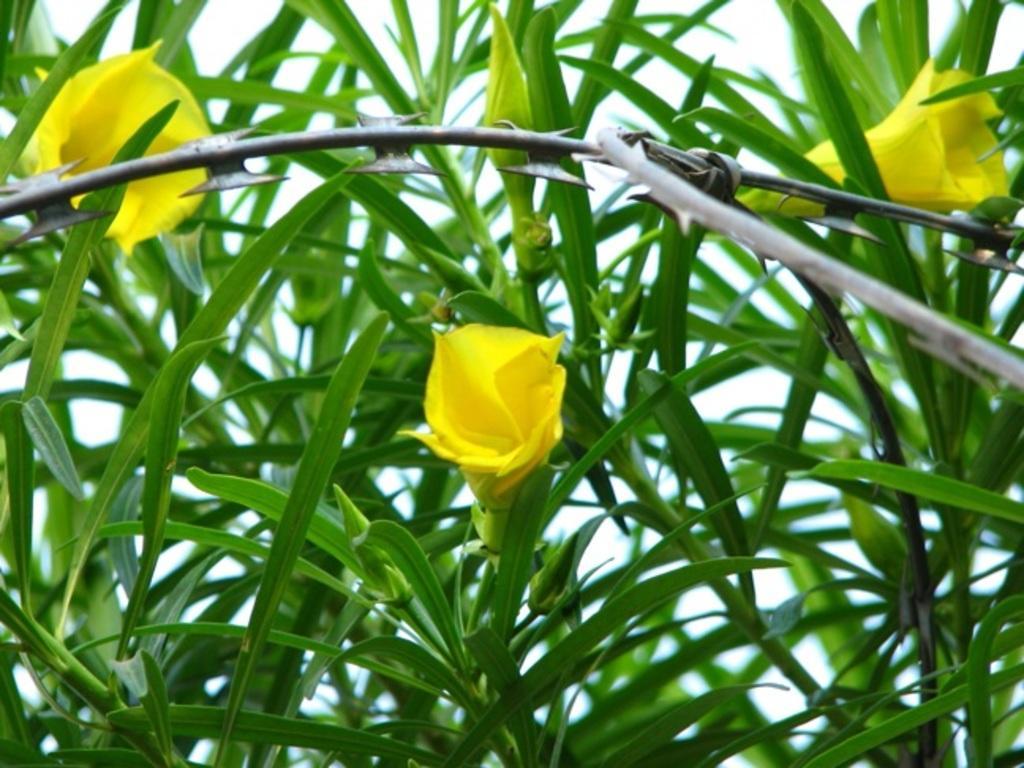In one or two sentences, can you explain what this image depicts? This image is taken outdoors. In this image there is a plant with green leaves and yellow flowers. 